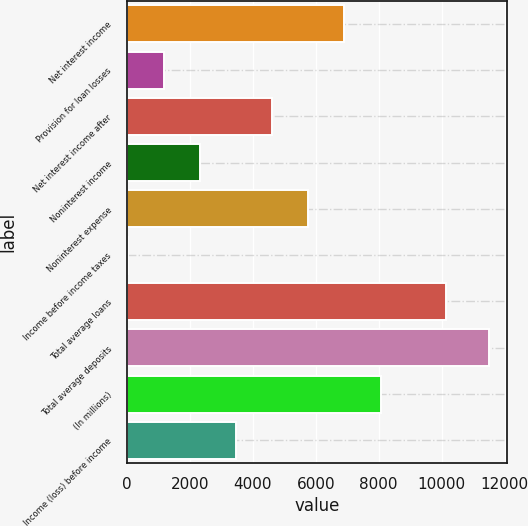Convert chart. <chart><loc_0><loc_0><loc_500><loc_500><bar_chart><fcel>Net interest income<fcel>Provision for loan losses<fcel>Net interest income after<fcel>Noninterest income<fcel>Noninterest expense<fcel>Income before income taxes<fcel>Total average loans<fcel>Total average deposits<fcel>(In millions)<fcel>Income (loss) before income<nl><fcel>6914.6<fcel>1189.1<fcel>4624.4<fcel>2334.2<fcel>5769.5<fcel>44<fcel>10148<fcel>11495<fcel>8059.7<fcel>3479.3<nl></chart> 